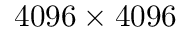<formula> <loc_0><loc_0><loc_500><loc_500>4 0 9 6 \times 4 0 9 6</formula> 